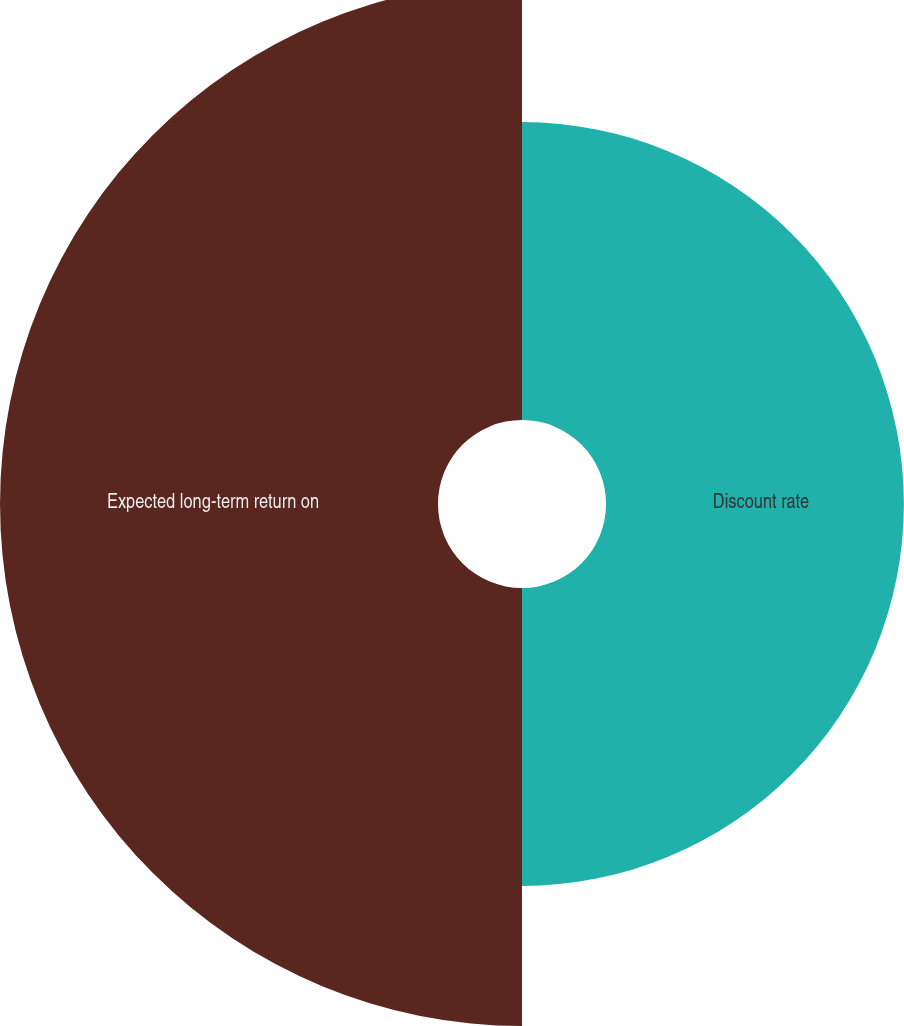<chart> <loc_0><loc_0><loc_500><loc_500><pie_chart><fcel>Discount rate<fcel>Expected long-term return on<nl><fcel>40.48%<fcel>59.52%<nl></chart> 